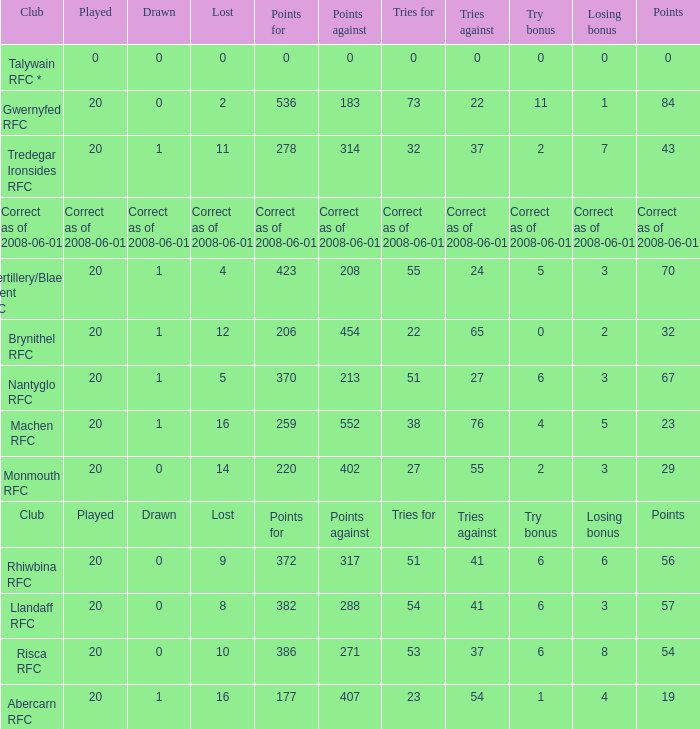What was the tries against when they had 32 tries for? 37.0. 